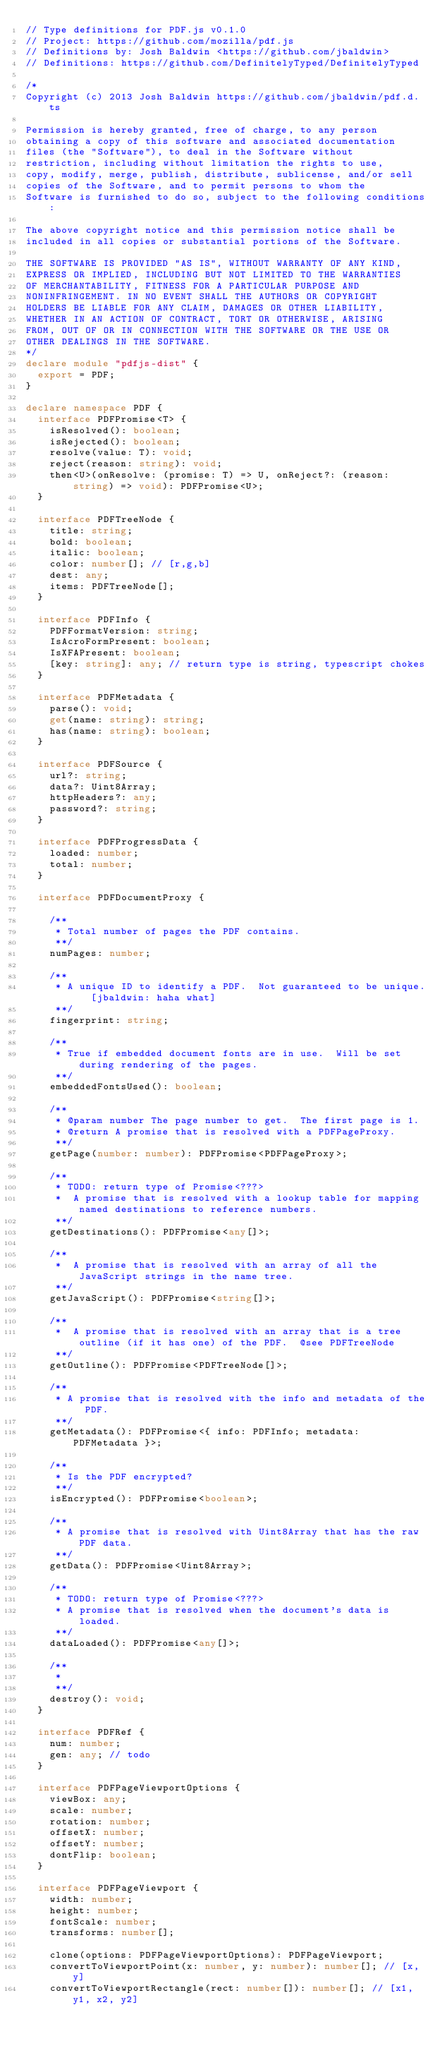Convert code to text. <code><loc_0><loc_0><loc_500><loc_500><_TypeScript_>// Type definitions for PDF.js v0.1.0
// Project: https://github.com/mozilla/pdf.js
// Definitions by: Josh Baldwin <https://github.com/jbaldwin>
// Definitions: https://github.com/DefinitelyTyped/DefinitelyTyped

/*
Copyright (c) 2013 Josh Baldwin https://github.com/jbaldwin/pdf.d.ts

Permission is hereby granted, free of charge, to any person
obtaining a copy of this software and associated documentation
files (the "Software"), to deal in the Software without
restriction, including without limitation the rights to use,
copy, modify, merge, publish, distribute, sublicense, and/or sell
copies of the Software, and to permit persons to whom the
Software is furnished to do so, subject to the following conditions:

The above copyright notice and this permission notice shall be
included in all copies or substantial portions of the Software.

THE SOFTWARE IS PROVIDED "AS IS", WITHOUT WARRANTY OF ANY KIND,
EXPRESS OR IMPLIED, INCLUDING BUT NOT LIMITED TO THE WARRANTIES
OF MERCHANTABILITY, FITNESS FOR A PARTICULAR PURPOSE AND
NONINFRINGEMENT. IN NO EVENT SHALL THE AUTHORS OR COPYRIGHT
HOLDERS BE LIABLE FOR ANY CLAIM, DAMAGES OR OTHER LIABILITY,
WHETHER IN AN ACTION OF CONTRACT, TORT OR OTHERWISE, ARISING
FROM, OUT OF OR IN CONNECTION WITH THE SOFTWARE OR THE USE OR
OTHER DEALINGS IN THE SOFTWARE.
*/
declare module "pdfjs-dist" {
  export = PDF;
}

declare namespace PDF {
  interface PDFPromise<T> {
    isResolved(): boolean;
    isRejected(): boolean;
    resolve(value: T): void;
    reject(reason: string): void;
    then<U>(onResolve: (promise: T) => U, onReject?: (reason: string) => void): PDFPromise<U>;
  }

  interface PDFTreeNode {
    title: string;
    bold: boolean;
    italic: boolean;
    color: number[]; // [r,g,b]
    dest: any;
    items: PDFTreeNode[];
  }

  interface PDFInfo {
    PDFFormatVersion: string;
    IsAcroFormPresent: boolean;
    IsXFAPresent: boolean;
    [key: string]: any;	// return type is string, typescript chokes
  }

  interface PDFMetadata {
    parse(): void;
    get(name: string): string;
    has(name: string): boolean;
  }

  interface PDFSource {
    url?: string;
    data?: Uint8Array;
    httpHeaders?: any;
    password?: string;
  }

  interface PDFProgressData {
    loaded: number;
    total: number;
  }

  interface PDFDocumentProxy {

    /**
     * Total number of pages the PDF contains.
     **/
    numPages: number;

    /**
     * A unique ID to identify a PDF.  Not guaranteed to be unique.  [jbaldwin: haha what]
     **/
    fingerprint: string;

    /**
     * True if embedded document fonts are in use.  Will be set during rendering of the pages.
     **/
    embeddedFontsUsed(): boolean;

    /**
     * @param number The page number to get.  The first page is 1.
     * @return A promise that is resolved with a PDFPageProxy.
     **/
    getPage(number: number): PDFPromise<PDFPageProxy>;

    /**
     * TODO: return type of Promise<???>
     *  A promise that is resolved with a lookup table for mapping named destinations to reference numbers.
     **/
    getDestinations(): PDFPromise<any[]>;

    /**
     *  A promise that is resolved with an array of all the JavaScript strings in the name tree.
     **/
    getJavaScript(): PDFPromise<string[]>;

    /**
     *  A promise that is resolved with an array that is a tree outline (if it has one) of the PDF.  @see PDFTreeNode
     **/
    getOutline(): PDFPromise<PDFTreeNode[]>;

    /**
     * A promise that is resolved with the info and metadata of the PDF.
     **/
    getMetadata(): PDFPromise<{ info: PDFInfo; metadata: PDFMetadata }>;

    /**
     * Is the PDF encrypted?
     **/
    isEncrypted(): PDFPromise<boolean>;

    /**
     * A promise that is resolved with Uint8Array that has the raw PDF data.
     **/
    getData(): PDFPromise<Uint8Array>;

    /**
     * TODO: return type of Promise<???>
     * A promise that is resolved when the document's data is loaded.
     **/
    dataLoaded(): PDFPromise<any[]>;

    /**
     *
     **/
    destroy(): void;
  }

  interface PDFRef {
    num: number;
    gen: any; // todo
  }

  interface PDFPageViewportOptions {
    viewBox: any;
    scale: number;
    rotation: number;
    offsetX: number;
    offsetY: number;
    dontFlip: boolean;
  }

  interface PDFPageViewport {
    width: number;
    height: number;
    fontScale: number;
    transforms: number[];

    clone(options: PDFPageViewportOptions): PDFPageViewport;
    convertToViewportPoint(x: number, y: number): number[]; // [x, y]
    convertToViewportRectangle(rect: number[]): number[]; // [x1, y1, x2, y2]</code> 